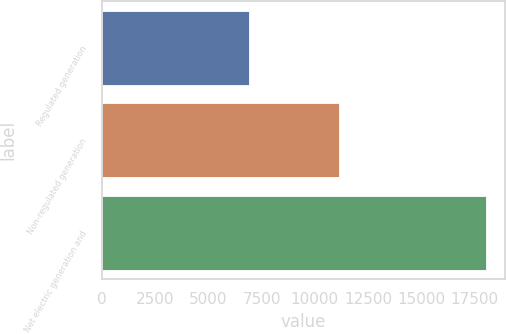Convert chart. <chart><loc_0><loc_0><loc_500><loc_500><bar_chart><fcel>Regulated generation<fcel>Non-regulated generation<fcel>Net electric generation and<nl><fcel>6914<fcel>11127<fcel>18041<nl></chart> 